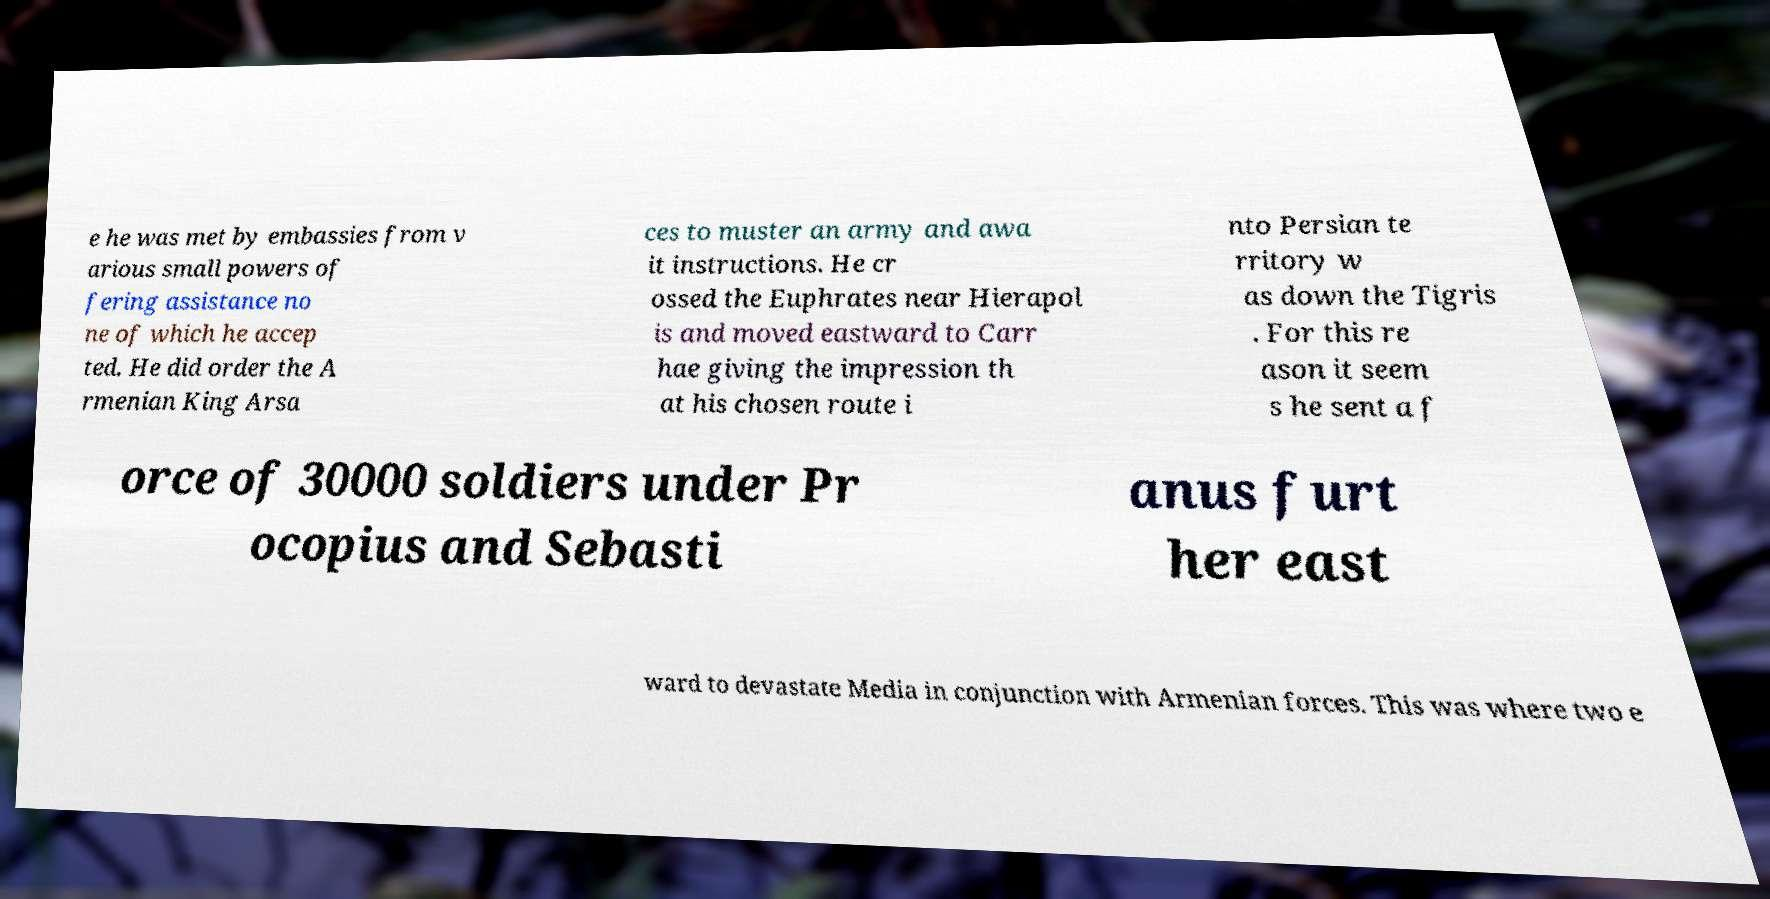Please read and relay the text visible in this image. What does it say? e he was met by embassies from v arious small powers of fering assistance no ne of which he accep ted. He did order the A rmenian King Arsa ces to muster an army and awa it instructions. He cr ossed the Euphrates near Hierapol is and moved eastward to Carr hae giving the impression th at his chosen route i nto Persian te rritory w as down the Tigris . For this re ason it seem s he sent a f orce of 30000 soldiers under Pr ocopius and Sebasti anus furt her east ward to devastate Media in conjunction with Armenian forces. This was where two e 